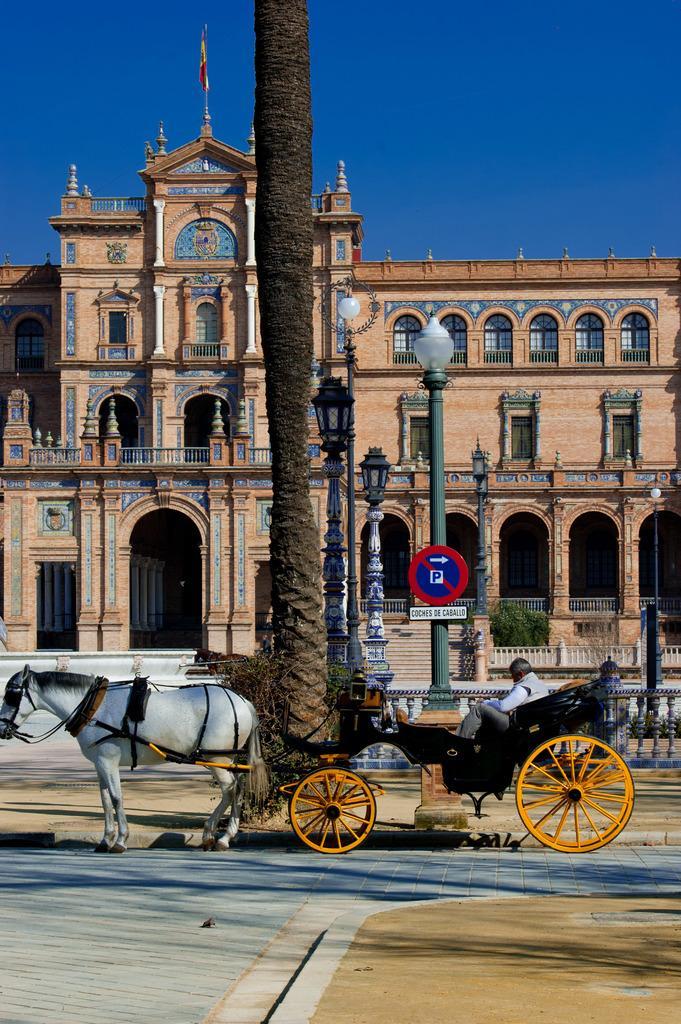Describe this image in one or two sentences. In this picture we can see a horse cart in the front, there is a person sitting in the cart, we can see a tree, poles, a signboard and lights in the middle, in the background there is a building and a flag, we can see the sky at the top of the picture, we can also see a plant in the background. 